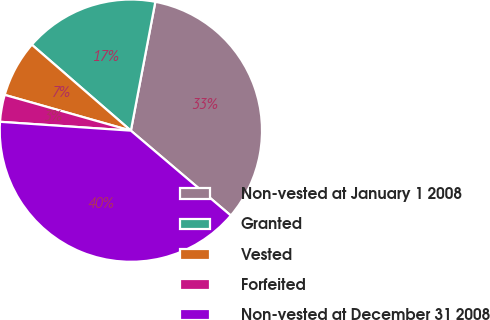Convert chart to OTSL. <chart><loc_0><loc_0><loc_500><loc_500><pie_chart><fcel>Non-vested at January 1 2008<fcel>Granted<fcel>Vested<fcel>Forfeited<fcel>Non-vested at December 31 2008<nl><fcel>33.22%<fcel>16.61%<fcel>6.98%<fcel>3.32%<fcel>39.87%<nl></chart> 